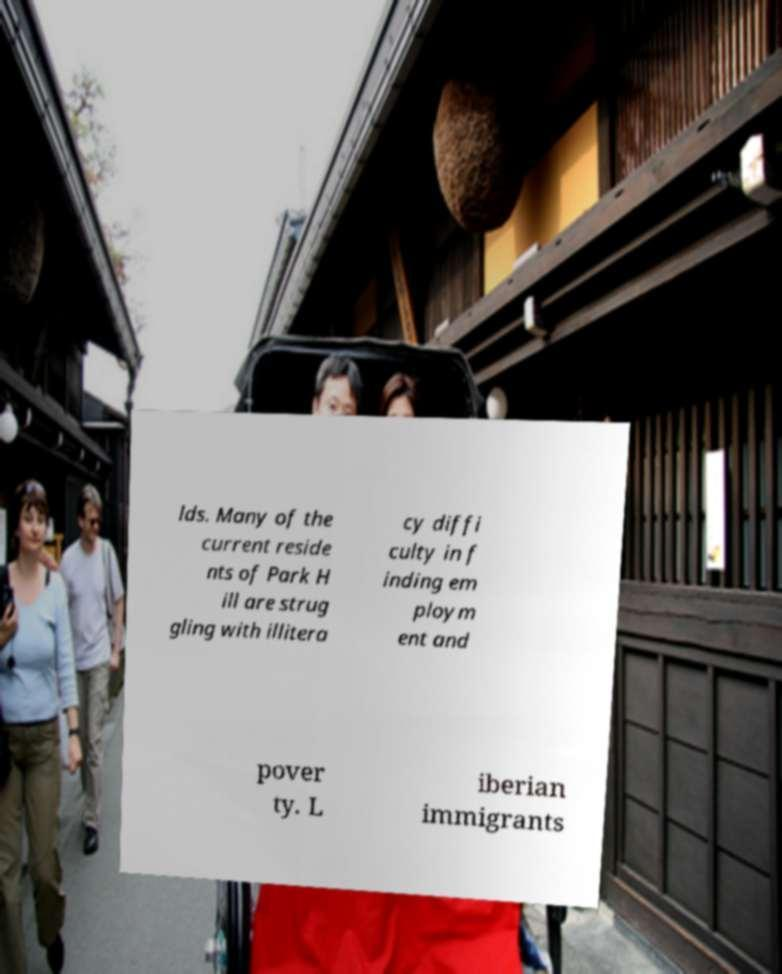Could you extract and type out the text from this image? lds. Many of the current reside nts of Park H ill are strug gling with illitera cy diffi culty in f inding em ploym ent and pover ty. L iberian immigrants 